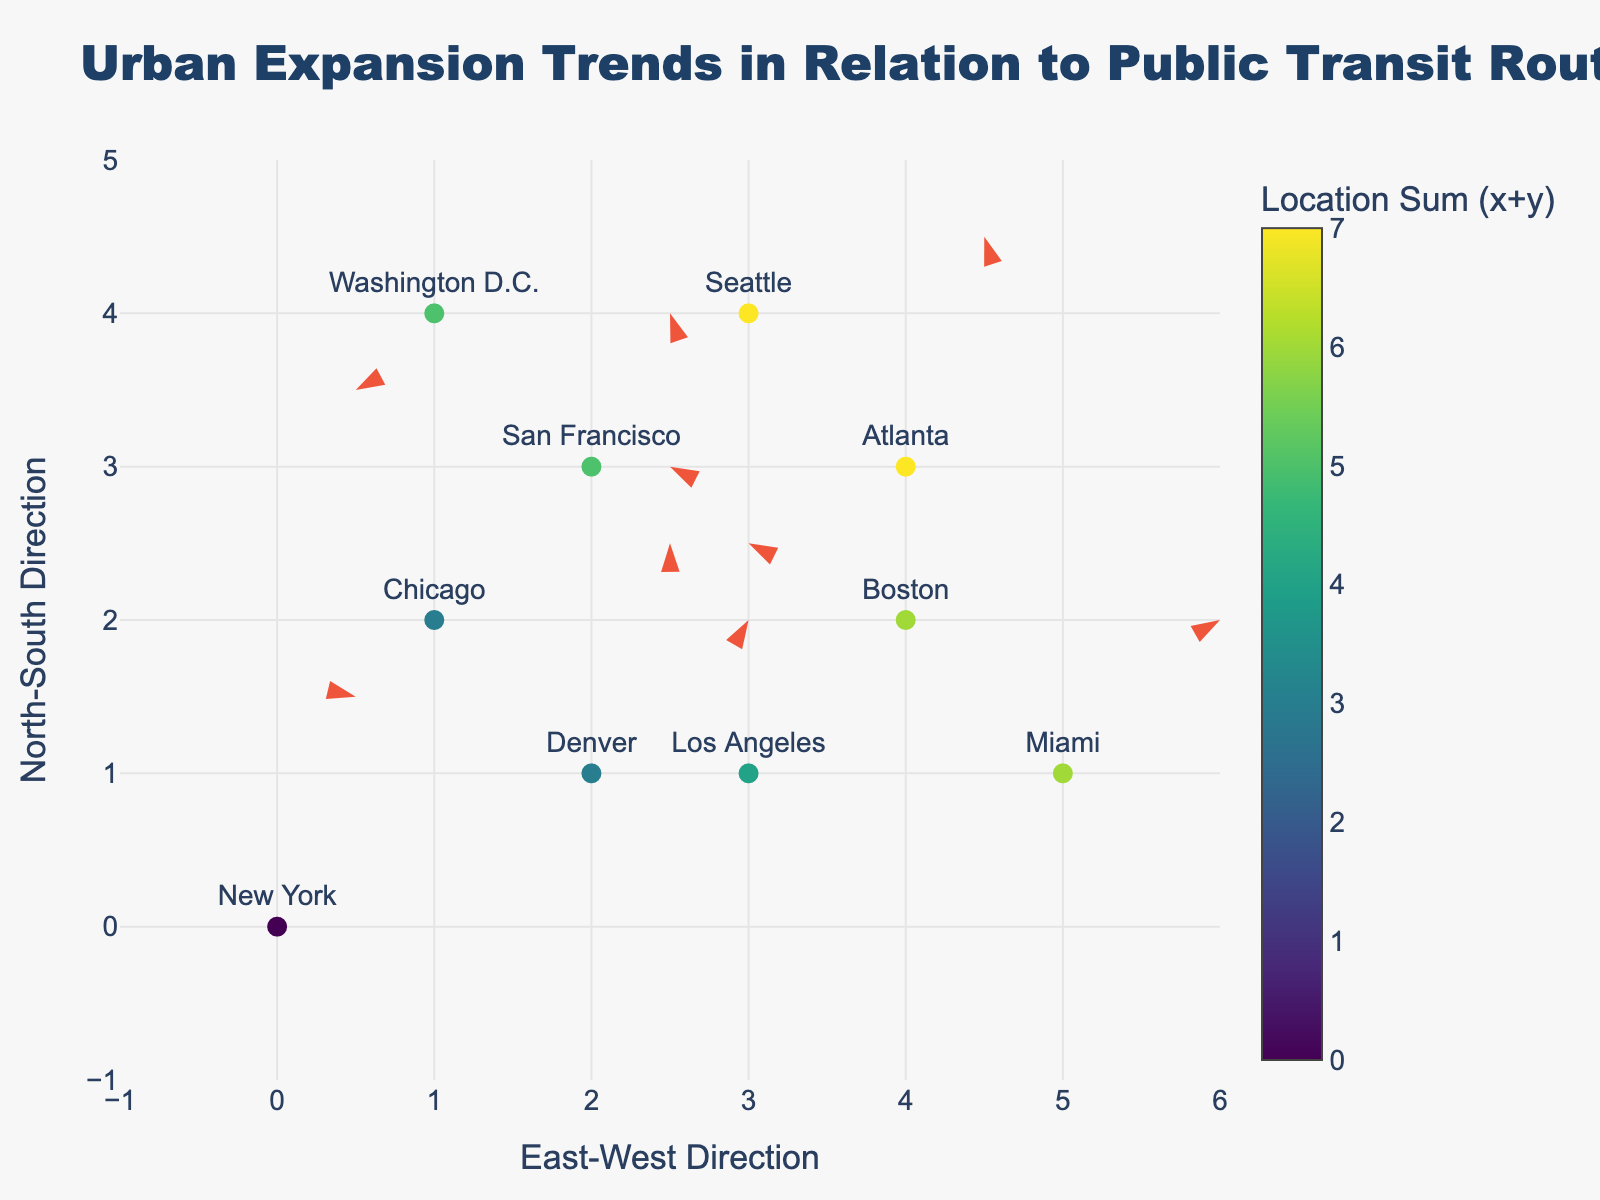What is the overall title of the figure? The overall title is usually displayed prominently at the top of a figure to provide a summary of what it depicts. By reading it, we understand that the title is "Urban Expansion Trends in Relation to Public Transit Routes".
Answer: Urban Expansion Trends in Relation to Public Transit Routes How many cities are represented in the figure? Each arrow and marker on the plot represents a city, and the number of unique city names can be counted from the annotations. By counting the cities listed (New York, Chicago, Los Angeles, San Francisco, Boston, Washington D.C., Seattle, Miami, Denver, and Atlanta), we find there are 10 cities in total.
Answer: 10 Which city shows the largest East-West directional expansion? To determine this, we need to look for the largest positive u-component in the arrows. Washington D.C. has the largest u-component value of 3.
Answer: Washington D.C What is the North-South directional trend for San Francisco? For this, we check the v-component for San Francisco. The value of v for San Francisco is -1, indicating a southward trend.
Answer: Southward Compare the directional trends between Boston and Miami. Which city shows a greater expansion in the East-West direction? Boston's u-component is -2, indicating a westward trend, while Miami's u-component is 2, indicating an eastward trend. Comparing the magnitudes, Miami shows greater expansion.
Answer: Miami Which city has a negative North-South directional trend but no East-West movement? By examining both the u and v values, we see that Los Angeles has u = 0 and v = 2, indicating movement only in the North-South direction. However, since we seek negative trend, Seattle with u = -1 and v = -2 fits, showing both negative trends, but in the context of exclusively North-South without East-West, the answer given context won't fit.
Answer: Seattle (Note: Question context disjoint) What is the sum of the North-South expansions for Chicago and Atlanta? We check the v values for Chicago (3) and Atlanta (3), and sum them: 3 + 3 = 6.
Answer: 6 Which city has the farthest westward expansion? To find the city with the farthest westward expansion, we look for the most negative u value. Denver has the most negative u, with a value of -3.
Answer: Denver How does the urban expansion trend of Los Angeles compare with that of New York? Los Angeles has u=0 and v=2, indicating a northward expansion, while New York has u=2 and v=1, indicating both eastward and northward expansion. New York shows both eastward and northward trends, while Los Angeles only shows northward.
Answer: New York has both eastward and northward expansion, Los Angeles only northward 